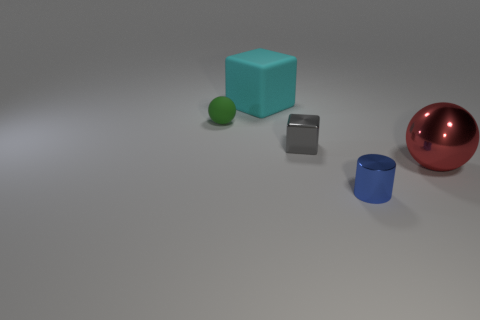Does this image give any indication about the size of the objects? The image does not provide a direct reference for scale, such as a familiar item or measurement unit. However, relative to each other, the objects vary in size, with the blue cube appearing larger in comparison to the spheres and cylinder. 